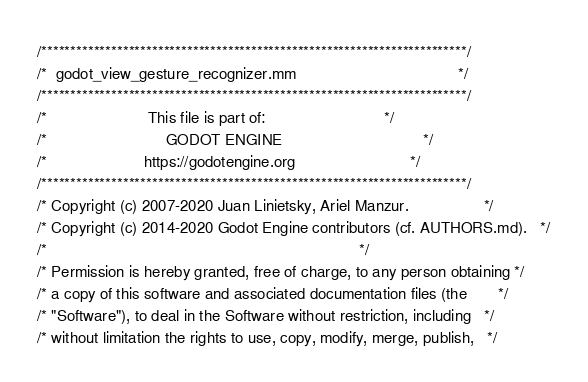Convert code to text. <code><loc_0><loc_0><loc_500><loc_500><_ObjectiveC_>/*************************************************************************/
/*  godot_view_gesture_recognizer.mm                                     */
/*************************************************************************/
/*                       This file is part of:                           */
/*                           GODOT ENGINE                                */
/*                      https://godotengine.org                          */
/*************************************************************************/
/* Copyright (c) 2007-2020 Juan Linietsky, Ariel Manzur.                 */
/* Copyright (c) 2014-2020 Godot Engine contributors (cf. AUTHORS.md).   */
/*                                                                       */
/* Permission is hereby granted, free of charge, to any person obtaining */
/* a copy of this software and associated documentation files (the       */
/* "Software"), to deal in the Software without restriction, including   */
/* without limitation the rights to use, copy, modify, merge, publish,   */</code> 